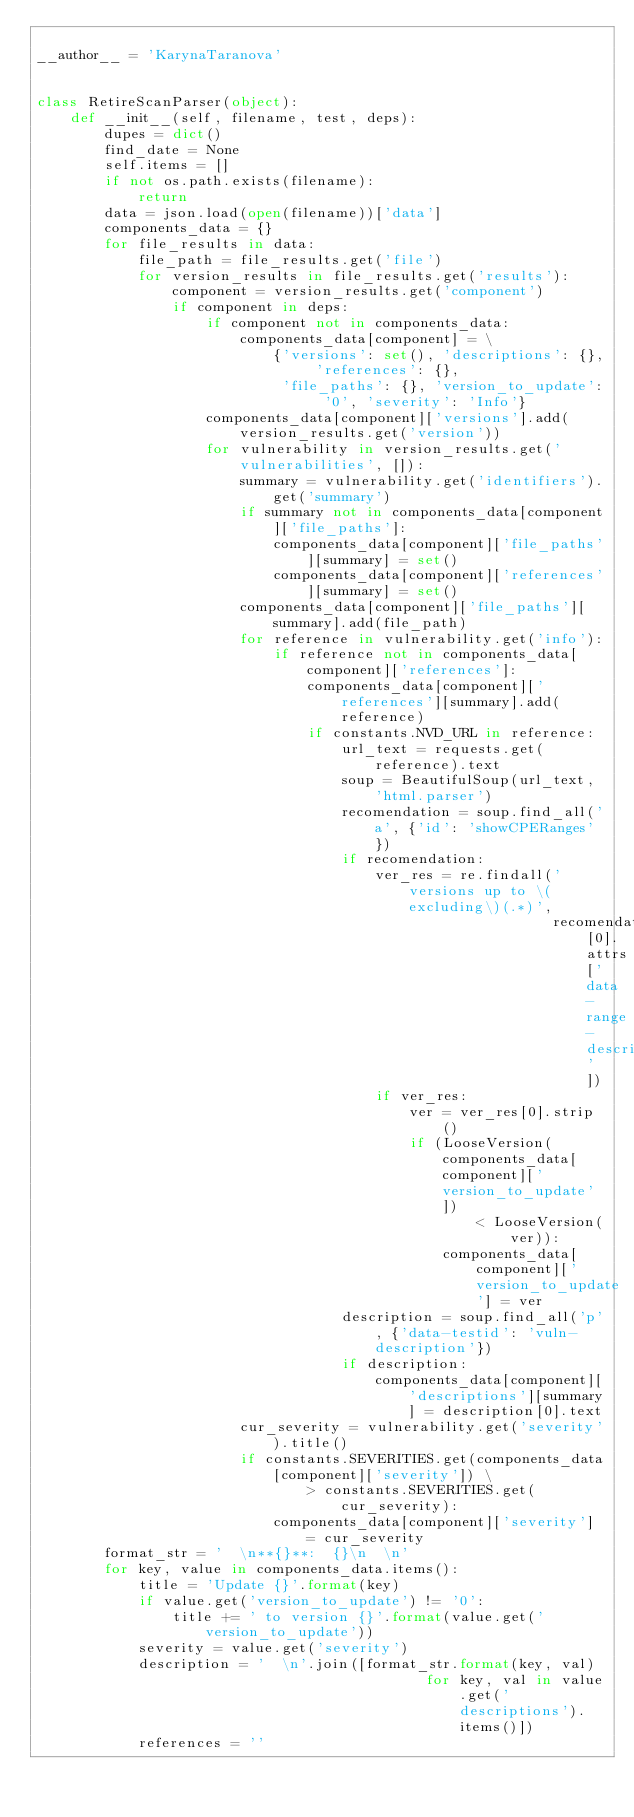<code> <loc_0><loc_0><loc_500><loc_500><_Python_>
__author__ = 'KarynaTaranova'


class RetireScanParser(object):
    def __init__(self, filename, test, deps):
        dupes = dict()
        find_date = None
        self.items = []
        if not os.path.exists(filename):
            return
        data = json.load(open(filename))['data']
        components_data = {}
        for file_results in data:
            file_path = file_results.get('file')
            for version_results in file_results.get('results'):
                component = version_results.get('component')
                if component in deps:
                    if component not in components_data:
                        components_data[component] = \
                            {'versions': set(), 'descriptions': {}, 'references': {},
                             'file_paths': {}, 'version_to_update': '0', 'severity': 'Info'}
                    components_data[component]['versions'].add(version_results.get('version'))
                    for vulnerability in version_results.get('vulnerabilities', []):
                        summary = vulnerability.get('identifiers').get('summary')
                        if summary not in components_data[component]['file_paths']:
                            components_data[component]['file_paths'][summary] = set()
                            components_data[component]['references'][summary] = set()
                        components_data[component]['file_paths'][summary].add(file_path)
                        for reference in vulnerability.get('info'):
                            if reference not in components_data[component]['references']:
                                components_data[component]['references'][summary].add(reference)
                                if constants.NVD_URL in reference:
                                    url_text = requests.get(reference).text
                                    soup = BeautifulSoup(url_text, 'html.parser')
                                    recomendation = soup.find_all('a', {'id': 'showCPERanges'})
                                    if recomendation:
                                        ver_res = re.findall('versions up to \(excluding\)(.*)',
                                                             recomendation[0].attrs['data-range-description'])
                                        if ver_res:
                                            ver = ver_res[0].strip()
                                            if (LooseVersion(components_data[component]['version_to_update'])
                                                    < LooseVersion(ver)):
                                                components_data[component]['version_to_update'] = ver
                                    description = soup.find_all('p', {'data-testid': 'vuln-description'})
                                    if description:
                                        components_data[component]['descriptions'][summary] = description[0].text
                        cur_severity = vulnerability.get('severity').title()
                        if constants.SEVERITIES.get(components_data[component]['severity']) \
                                > constants.SEVERITIES.get(cur_severity):
                            components_data[component]['severity'] = cur_severity
        format_str = '  \n**{}**:  {}\n  \n'
        for key, value in components_data.items():
            title = 'Update {}'.format(key)
            if value.get('version_to_update') != '0':
                title += ' to version {}'.format(value.get('version_to_update'))
            severity = value.get('severity')
            description = '  \n'.join([format_str.format(key, val)
                                              for key, val in value.get('descriptions').items()])
            references = ''</code> 